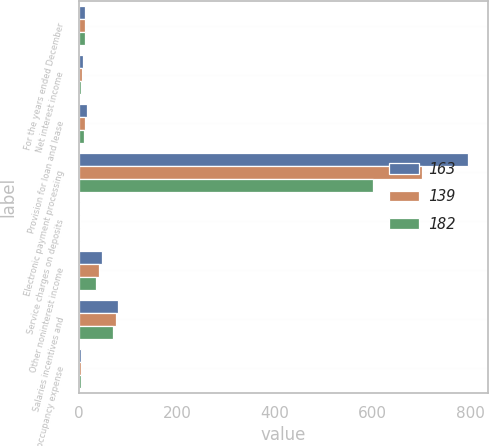Convert chart to OTSL. <chart><loc_0><loc_0><loc_500><loc_500><stacked_bar_chart><ecel><fcel>For the years ended December<fcel>Net interest income<fcel>Provision for loan and lease<fcel>Electronic payment processing<fcel>Service charges on deposits<fcel>Other noninterest income<fcel>Salaries incentives and<fcel>Net occupancy expense<nl><fcel>163<fcel>11<fcel>7<fcel>16<fcel>796<fcel>1<fcel>46<fcel>80<fcel>4<nl><fcel>139<fcel>11<fcel>6<fcel>11<fcel>700<fcel>1<fcel>41<fcel>75<fcel>4<nl><fcel>182<fcel>11<fcel>3<fcel>9<fcel>601<fcel>1<fcel>35<fcel>70<fcel>3<nl></chart> 